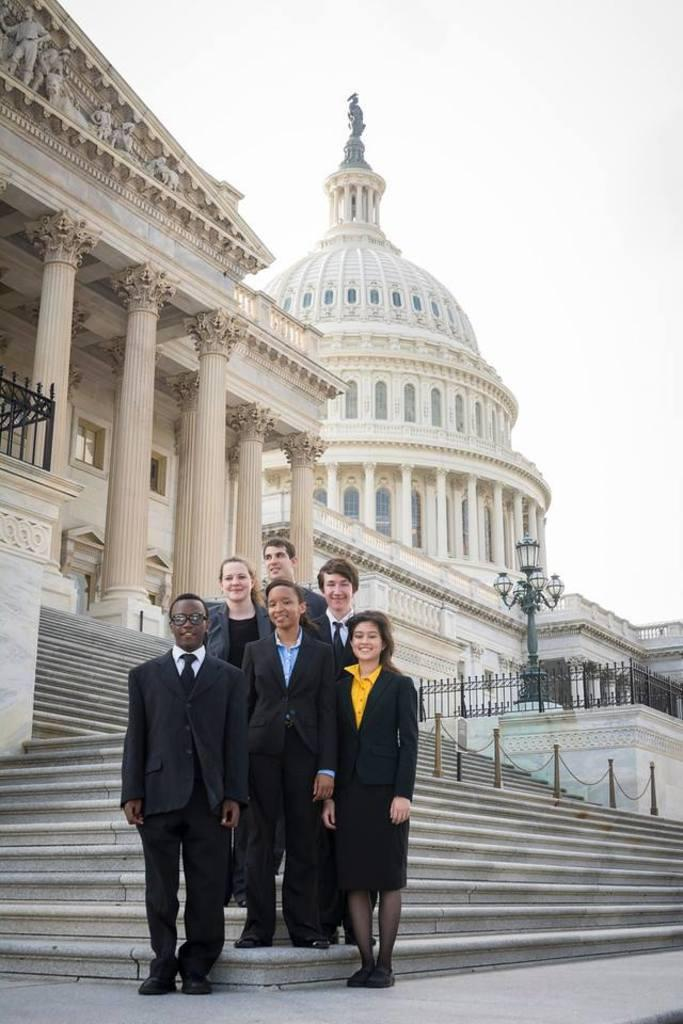How many people are in the image? There is a group of people in the image. What colors are the people wearing? The people are wearing yellow, blue, black, and white color dresses. What can be seen in the background of the image? There are buildings, a light pole, railing, and the sky visible in the background of the image. What type of grain is being harvested by the animal in the image? There is no animal or grain present in the image. What street is the group of people walking on in the image? The image does not show a street, and there is no indication that the people are walking. 